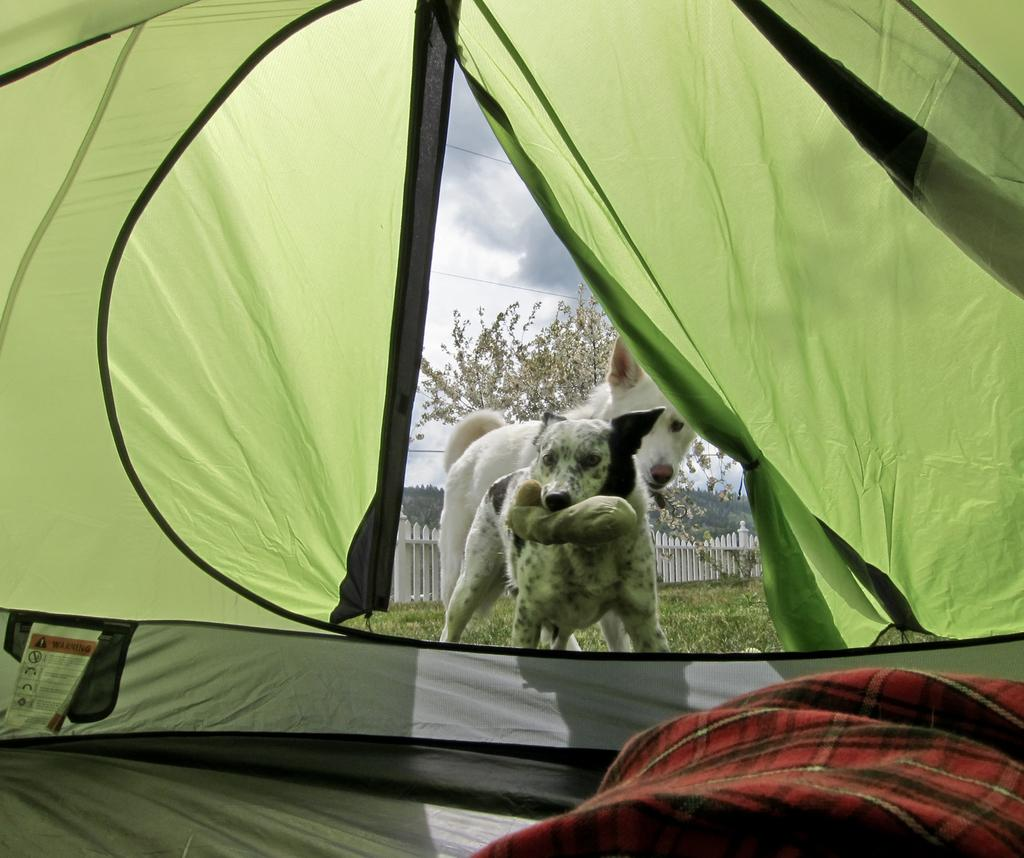How many dogs are present in the image? There are two dogs in the image. What structure can be seen in the image? There is a tent in the image. What type of natural environment is visible in the background of the image? There are trees in the background of the image. What is visible at the top of the image? The sky is visible at the top of the image. Where is the spoon located in the image? There is no spoon present in the image. Can you describe the toad's habitat in the image? There is no toad present in the image. 